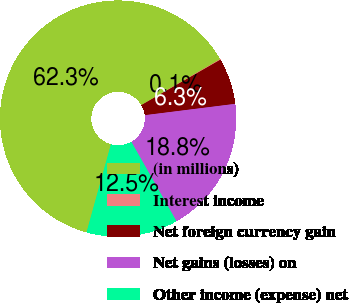Convert chart to OTSL. <chart><loc_0><loc_0><loc_500><loc_500><pie_chart><fcel>(in millions)<fcel>Interest income<fcel>Net foreign currency gain<fcel>Net gains (losses) on<fcel>Other income (expense) net<nl><fcel>62.3%<fcel>0.09%<fcel>6.31%<fcel>18.76%<fcel>12.53%<nl></chart> 